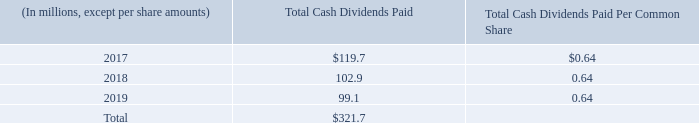Dividends
The following table shows our total cash dividends paid in the years ended December 31:
On February 13, 2020, our Board of Directors declared a quarterly cash dividend of $0.16 per common share payable on March 20, 2020 to stockholders of record at the close of business on March 6, 2020. The estimated amount of this dividend payment is $24.8 million based on 154.7 million shares of our common stock issued and outstanding as of February 21, 2020.
The dividend payments discussed above are recorded as reductions to cash and cash equivalents and retained earnings on our Consolidated Balance Sheets. Our credit facility and our senior notes contain covenants that restrict our ability to declare or pay dividends and repurchase stock. However, we do not believe these covenants are likely to materially limit the future payment of quarterly cash dividends on our common stock. From time to time, we may consider other means of returning value to our stockholders based on our consolidated financial condition and results of operations. There is no guarantee that our Board of Directors will declare any further dividends.
What is the Total Cash Dividends Paid for 2017?
Answer scale should be: million. $119.7. What years are included in the table? 2017, 2018, 2019. What did the Board of Directors declare on February 13, 2020? A quarterly cash dividend of $0.16 per common share payable on march 20, 2020 to stockholders of record at the close of business on march 6, 2020. What is the total cash dividends paid for 2019 expressed as percentage of the total cash dividends paid for all years?
Answer scale should be: percent. 99.1/321.7
Answer: 30.81. About how many common shares were there in total for all years?
Answer scale should be: million. 321.7/0.64
Answer: 502.66. Including the declared quarterly cash dividend on February 13, 2020, what is the Total Cash Dividends Paid as of February 21, 2020 in dollars?
Answer scale should be: million. 321.7+24.8
Answer: 346.5. 